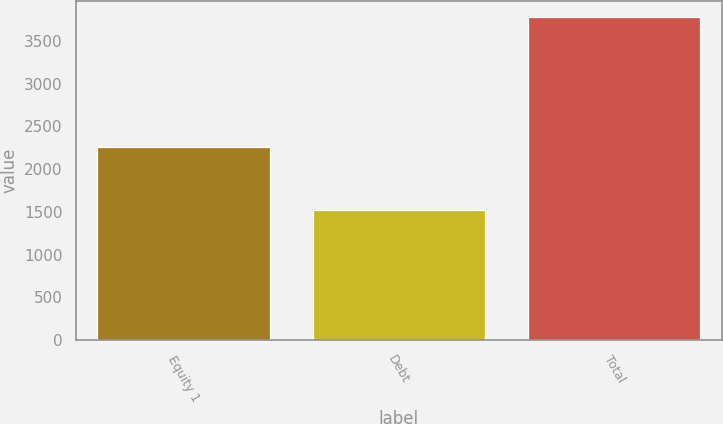Convert chart to OTSL. <chart><loc_0><loc_0><loc_500><loc_500><bar_chart><fcel>Equity 1<fcel>Debt<fcel>Total<nl><fcel>2256<fcel>1522<fcel>3778<nl></chart> 